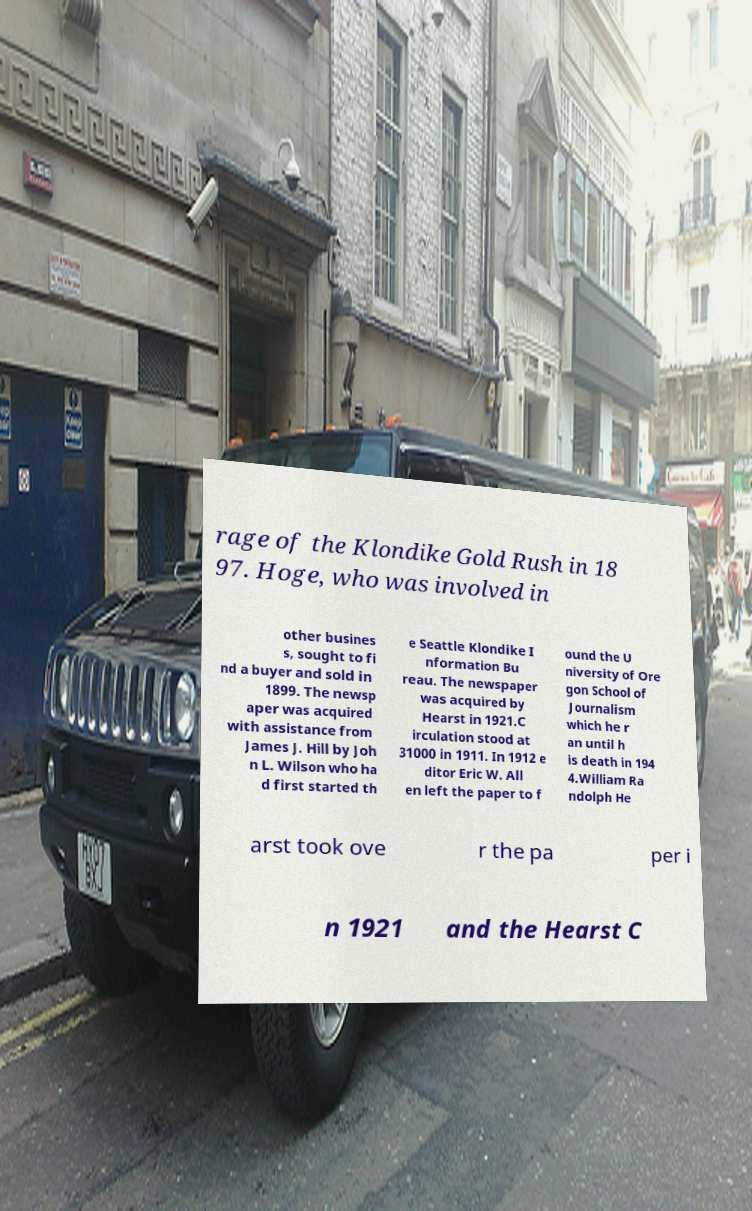What messages or text are displayed in this image? I need them in a readable, typed format. rage of the Klondike Gold Rush in 18 97. Hoge, who was involved in other busines s, sought to fi nd a buyer and sold in 1899. The newsp aper was acquired with assistance from James J. Hill by Joh n L. Wilson who ha d first started th e Seattle Klondike I nformation Bu reau. The newspaper was acquired by Hearst in 1921.C irculation stood at 31000 in 1911. In 1912 e ditor Eric W. All en left the paper to f ound the U niversity of Ore gon School of Journalism which he r an until h is death in 194 4.William Ra ndolph He arst took ove r the pa per i n 1921 and the Hearst C 